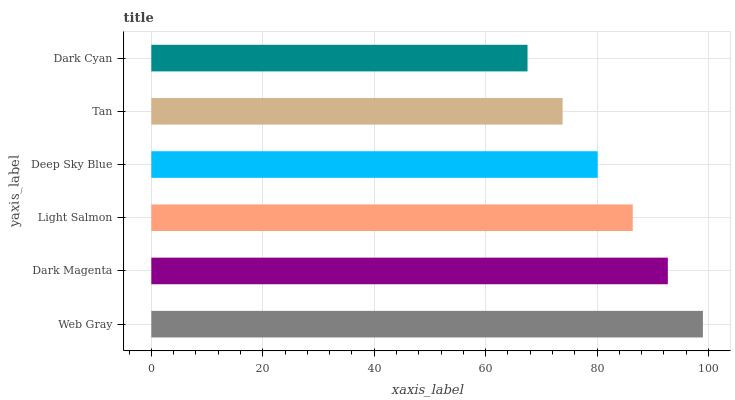Is Dark Cyan the minimum?
Answer yes or no. Yes. Is Web Gray the maximum?
Answer yes or no. Yes. Is Dark Magenta the minimum?
Answer yes or no. No. Is Dark Magenta the maximum?
Answer yes or no. No. Is Web Gray greater than Dark Magenta?
Answer yes or no. Yes. Is Dark Magenta less than Web Gray?
Answer yes or no. Yes. Is Dark Magenta greater than Web Gray?
Answer yes or no. No. Is Web Gray less than Dark Magenta?
Answer yes or no. No. Is Light Salmon the high median?
Answer yes or no. Yes. Is Deep Sky Blue the low median?
Answer yes or no. Yes. Is Deep Sky Blue the high median?
Answer yes or no. No. Is Web Gray the low median?
Answer yes or no. No. 